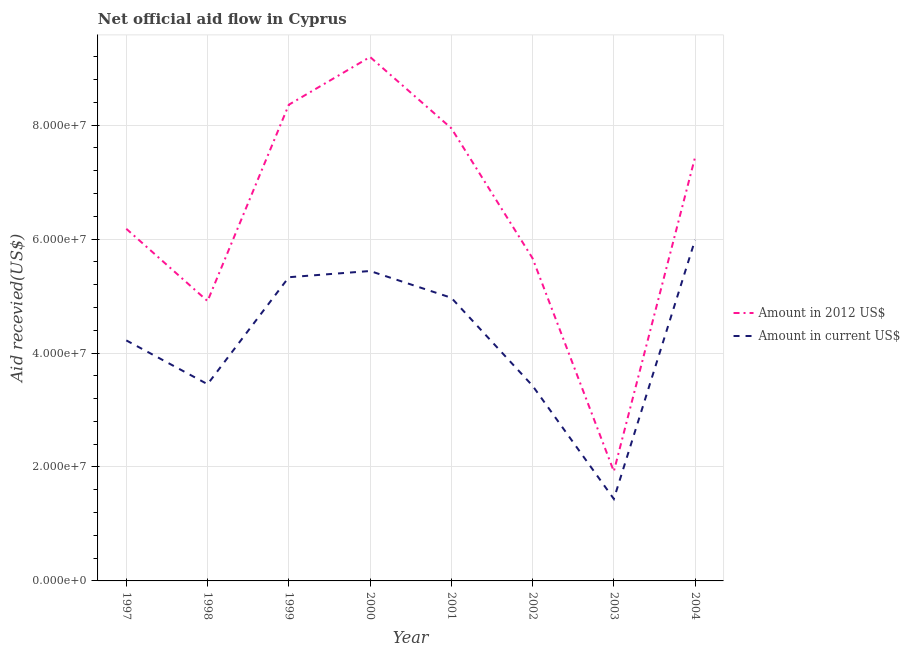How many different coloured lines are there?
Give a very brief answer. 2. What is the amount of aid received(expressed in 2012 us$) in 2002?
Offer a very short reply. 5.66e+07. Across all years, what is the maximum amount of aid received(expressed in us$)?
Give a very brief answer. 5.99e+07. Across all years, what is the minimum amount of aid received(expressed in 2012 us$)?
Your response must be concise. 1.92e+07. What is the total amount of aid received(expressed in us$) in the graph?
Provide a succinct answer. 3.43e+08. What is the difference between the amount of aid received(expressed in us$) in 1997 and that in 2002?
Give a very brief answer. 7.97e+06. What is the difference between the amount of aid received(expressed in us$) in 1998 and the amount of aid received(expressed in 2012 us$) in 2002?
Provide a short and direct response. -2.21e+07. What is the average amount of aid received(expressed in 2012 us$) per year?
Your response must be concise. 6.45e+07. In the year 1999, what is the difference between the amount of aid received(expressed in 2012 us$) and amount of aid received(expressed in us$)?
Your answer should be compact. 3.03e+07. In how many years, is the amount of aid received(expressed in us$) greater than 56000000 US$?
Make the answer very short. 1. What is the ratio of the amount of aid received(expressed in us$) in 2001 to that in 2002?
Offer a very short reply. 1.45. Is the amount of aid received(expressed in us$) in 1997 less than that in 1998?
Offer a very short reply. No. What is the difference between the highest and the second highest amount of aid received(expressed in 2012 us$)?
Give a very brief answer. 8.38e+06. What is the difference between the highest and the lowest amount of aid received(expressed in us$)?
Your response must be concise. 4.55e+07. Is the sum of the amount of aid received(expressed in us$) in 1998 and 2004 greater than the maximum amount of aid received(expressed in 2012 us$) across all years?
Ensure brevity in your answer.  Yes. Does the amount of aid received(expressed in us$) monotonically increase over the years?
Keep it short and to the point. No. Is the amount of aid received(expressed in us$) strictly less than the amount of aid received(expressed in 2012 us$) over the years?
Offer a terse response. Yes. How many lines are there?
Your answer should be very brief. 2. How many years are there in the graph?
Your answer should be compact. 8. Does the graph contain any zero values?
Make the answer very short. No. Does the graph contain grids?
Offer a very short reply. Yes. Where does the legend appear in the graph?
Your answer should be compact. Center right. How many legend labels are there?
Keep it short and to the point. 2. What is the title of the graph?
Ensure brevity in your answer.  Net official aid flow in Cyprus. What is the label or title of the Y-axis?
Give a very brief answer. Aid recevied(US$). What is the Aid recevied(US$) of Amount in 2012 US$ in 1997?
Keep it short and to the point. 6.18e+07. What is the Aid recevied(US$) in Amount in current US$ in 1997?
Give a very brief answer. 4.22e+07. What is the Aid recevied(US$) of Amount in 2012 US$ in 1998?
Your answer should be very brief. 4.91e+07. What is the Aid recevied(US$) in Amount in current US$ in 1998?
Give a very brief answer. 3.45e+07. What is the Aid recevied(US$) in Amount in 2012 US$ in 1999?
Your response must be concise. 8.36e+07. What is the Aid recevied(US$) of Amount in current US$ in 1999?
Offer a very short reply. 5.33e+07. What is the Aid recevied(US$) in Amount in 2012 US$ in 2000?
Keep it short and to the point. 9.20e+07. What is the Aid recevied(US$) of Amount in current US$ in 2000?
Offer a terse response. 5.44e+07. What is the Aid recevied(US$) of Amount in 2012 US$ in 2001?
Offer a very short reply. 7.95e+07. What is the Aid recevied(US$) of Amount in current US$ in 2001?
Make the answer very short. 4.97e+07. What is the Aid recevied(US$) in Amount in 2012 US$ in 2002?
Give a very brief answer. 5.66e+07. What is the Aid recevied(US$) of Amount in current US$ in 2002?
Provide a short and direct response. 3.42e+07. What is the Aid recevied(US$) of Amount in 2012 US$ in 2003?
Give a very brief answer. 1.92e+07. What is the Aid recevied(US$) of Amount in current US$ in 2003?
Keep it short and to the point. 1.44e+07. What is the Aid recevied(US$) of Amount in 2012 US$ in 2004?
Give a very brief answer. 7.44e+07. What is the Aid recevied(US$) in Amount in current US$ in 2004?
Your answer should be compact. 5.99e+07. Across all years, what is the maximum Aid recevied(US$) in Amount in 2012 US$?
Your answer should be compact. 9.20e+07. Across all years, what is the maximum Aid recevied(US$) of Amount in current US$?
Make the answer very short. 5.99e+07. Across all years, what is the minimum Aid recevied(US$) in Amount in 2012 US$?
Provide a short and direct response. 1.92e+07. Across all years, what is the minimum Aid recevied(US$) of Amount in current US$?
Provide a succinct answer. 1.44e+07. What is the total Aid recevied(US$) of Amount in 2012 US$ in the graph?
Offer a very short reply. 5.16e+08. What is the total Aid recevied(US$) of Amount in current US$ in the graph?
Offer a very short reply. 3.43e+08. What is the difference between the Aid recevied(US$) of Amount in 2012 US$ in 1997 and that in 1998?
Make the answer very short. 1.27e+07. What is the difference between the Aid recevied(US$) of Amount in current US$ in 1997 and that in 1998?
Your answer should be compact. 7.69e+06. What is the difference between the Aid recevied(US$) of Amount in 2012 US$ in 1997 and that in 1999?
Your answer should be very brief. -2.18e+07. What is the difference between the Aid recevied(US$) of Amount in current US$ in 1997 and that in 1999?
Your answer should be compact. -1.11e+07. What is the difference between the Aid recevied(US$) in Amount in 2012 US$ in 1997 and that in 2000?
Provide a succinct answer. -3.02e+07. What is the difference between the Aid recevied(US$) of Amount in current US$ in 1997 and that in 2000?
Keep it short and to the point. -1.22e+07. What is the difference between the Aid recevied(US$) of Amount in 2012 US$ in 1997 and that in 2001?
Your answer should be compact. -1.76e+07. What is the difference between the Aid recevied(US$) of Amount in current US$ in 1997 and that in 2001?
Offer a terse response. -7.48e+06. What is the difference between the Aid recevied(US$) in Amount in 2012 US$ in 1997 and that in 2002?
Provide a succinct answer. 5.18e+06. What is the difference between the Aid recevied(US$) in Amount in current US$ in 1997 and that in 2002?
Provide a short and direct response. 7.97e+06. What is the difference between the Aid recevied(US$) of Amount in 2012 US$ in 1997 and that in 2003?
Keep it short and to the point. 4.26e+07. What is the difference between the Aid recevied(US$) in Amount in current US$ in 1997 and that in 2003?
Make the answer very short. 2.78e+07. What is the difference between the Aid recevied(US$) of Amount in 2012 US$ in 1997 and that in 2004?
Provide a succinct answer. -1.26e+07. What is the difference between the Aid recevied(US$) of Amount in current US$ in 1997 and that in 2004?
Your answer should be compact. -1.76e+07. What is the difference between the Aid recevied(US$) in Amount in 2012 US$ in 1998 and that in 1999?
Offer a very short reply. -3.45e+07. What is the difference between the Aid recevied(US$) in Amount in current US$ in 1998 and that in 1999?
Provide a short and direct response. -1.88e+07. What is the difference between the Aid recevied(US$) in Amount in 2012 US$ in 1998 and that in 2000?
Offer a terse response. -4.28e+07. What is the difference between the Aid recevied(US$) in Amount in current US$ in 1998 and that in 2000?
Your response must be concise. -1.99e+07. What is the difference between the Aid recevied(US$) in Amount in 2012 US$ in 1998 and that in 2001?
Your response must be concise. -3.03e+07. What is the difference between the Aid recevied(US$) in Amount in current US$ in 1998 and that in 2001?
Your response must be concise. -1.52e+07. What is the difference between the Aid recevied(US$) in Amount in 2012 US$ in 1998 and that in 2002?
Offer a very short reply. -7.51e+06. What is the difference between the Aid recevied(US$) in Amount in current US$ in 1998 and that in 2002?
Your answer should be compact. 2.80e+05. What is the difference between the Aid recevied(US$) of Amount in 2012 US$ in 1998 and that in 2003?
Your answer should be very brief. 2.99e+07. What is the difference between the Aid recevied(US$) of Amount in current US$ in 1998 and that in 2003?
Ensure brevity in your answer.  2.01e+07. What is the difference between the Aid recevied(US$) of Amount in 2012 US$ in 1998 and that in 2004?
Offer a terse response. -2.53e+07. What is the difference between the Aid recevied(US$) in Amount in current US$ in 1998 and that in 2004?
Give a very brief answer. -2.53e+07. What is the difference between the Aid recevied(US$) of Amount in 2012 US$ in 1999 and that in 2000?
Make the answer very short. -8.38e+06. What is the difference between the Aid recevied(US$) of Amount in current US$ in 1999 and that in 2000?
Offer a terse response. -1.09e+06. What is the difference between the Aid recevied(US$) in Amount in 2012 US$ in 1999 and that in 2001?
Ensure brevity in your answer.  4.13e+06. What is the difference between the Aid recevied(US$) in Amount in current US$ in 1999 and that in 2001?
Give a very brief answer. 3.61e+06. What is the difference between the Aid recevied(US$) in Amount in 2012 US$ in 1999 and that in 2002?
Your answer should be very brief. 2.70e+07. What is the difference between the Aid recevied(US$) of Amount in current US$ in 1999 and that in 2002?
Offer a terse response. 1.91e+07. What is the difference between the Aid recevied(US$) in Amount in 2012 US$ in 1999 and that in 2003?
Your answer should be compact. 6.44e+07. What is the difference between the Aid recevied(US$) in Amount in current US$ in 1999 and that in 2003?
Offer a terse response. 3.89e+07. What is the difference between the Aid recevied(US$) of Amount in 2012 US$ in 1999 and that in 2004?
Your answer should be compact. 9.20e+06. What is the difference between the Aid recevied(US$) in Amount in current US$ in 1999 and that in 2004?
Your answer should be compact. -6.55e+06. What is the difference between the Aid recevied(US$) of Amount in 2012 US$ in 2000 and that in 2001?
Make the answer very short. 1.25e+07. What is the difference between the Aid recevied(US$) in Amount in current US$ in 2000 and that in 2001?
Make the answer very short. 4.70e+06. What is the difference between the Aid recevied(US$) in Amount in 2012 US$ in 2000 and that in 2002?
Make the answer very short. 3.53e+07. What is the difference between the Aid recevied(US$) of Amount in current US$ in 2000 and that in 2002?
Your response must be concise. 2.02e+07. What is the difference between the Aid recevied(US$) in Amount in 2012 US$ in 2000 and that in 2003?
Your response must be concise. 7.27e+07. What is the difference between the Aid recevied(US$) in Amount in current US$ in 2000 and that in 2003?
Your answer should be very brief. 4.00e+07. What is the difference between the Aid recevied(US$) in Amount in 2012 US$ in 2000 and that in 2004?
Your response must be concise. 1.76e+07. What is the difference between the Aid recevied(US$) in Amount in current US$ in 2000 and that in 2004?
Your answer should be compact. -5.46e+06. What is the difference between the Aid recevied(US$) in Amount in 2012 US$ in 2001 and that in 2002?
Give a very brief answer. 2.28e+07. What is the difference between the Aid recevied(US$) in Amount in current US$ in 2001 and that in 2002?
Make the answer very short. 1.54e+07. What is the difference between the Aid recevied(US$) in Amount in 2012 US$ in 2001 and that in 2003?
Make the answer very short. 6.02e+07. What is the difference between the Aid recevied(US$) of Amount in current US$ in 2001 and that in 2003?
Offer a very short reply. 3.53e+07. What is the difference between the Aid recevied(US$) of Amount in 2012 US$ in 2001 and that in 2004?
Keep it short and to the point. 5.07e+06. What is the difference between the Aid recevied(US$) in Amount in current US$ in 2001 and that in 2004?
Ensure brevity in your answer.  -1.02e+07. What is the difference between the Aid recevied(US$) of Amount in 2012 US$ in 2002 and that in 2003?
Ensure brevity in your answer.  3.74e+07. What is the difference between the Aid recevied(US$) in Amount in current US$ in 2002 and that in 2003?
Keep it short and to the point. 1.99e+07. What is the difference between the Aid recevied(US$) of Amount in 2012 US$ in 2002 and that in 2004?
Your answer should be compact. -1.78e+07. What is the difference between the Aid recevied(US$) of Amount in current US$ in 2002 and that in 2004?
Give a very brief answer. -2.56e+07. What is the difference between the Aid recevied(US$) in Amount in 2012 US$ in 2003 and that in 2004?
Your response must be concise. -5.52e+07. What is the difference between the Aid recevied(US$) of Amount in current US$ in 2003 and that in 2004?
Provide a succinct answer. -4.55e+07. What is the difference between the Aid recevied(US$) of Amount in 2012 US$ in 1997 and the Aid recevied(US$) of Amount in current US$ in 1998?
Provide a short and direct response. 2.73e+07. What is the difference between the Aid recevied(US$) of Amount in 2012 US$ in 1997 and the Aid recevied(US$) of Amount in current US$ in 1999?
Make the answer very short. 8.50e+06. What is the difference between the Aid recevied(US$) in Amount in 2012 US$ in 1997 and the Aid recevied(US$) in Amount in current US$ in 2000?
Your answer should be compact. 7.41e+06. What is the difference between the Aid recevied(US$) of Amount in 2012 US$ in 1997 and the Aid recevied(US$) of Amount in current US$ in 2001?
Give a very brief answer. 1.21e+07. What is the difference between the Aid recevied(US$) of Amount in 2012 US$ in 1997 and the Aid recevied(US$) of Amount in current US$ in 2002?
Make the answer very short. 2.76e+07. What is the difference between the Aid recevied(US$) in Amount in 2012 US$ in 1997 and the Aid recevied(US$) in Amount in current US$ in 2003?
Ensure brevity in your answer.  4.74e+07. What is the difference between the Aid recevied(US$) of Amount in 2012 US$ in 1997 and the Aid recevied(US$) of Amount in current US$ in 2004?
Keep it short and to the point. 1.95e+06. What is the difference between the Aid recevied(US$) of Amount in 2012 US$ in 1998 and the Aid recevied(US$) of Amount in current US$ in 1999?
Your answer should be very brief. -4.19e+06. What is the difference between the Aid recevied(US$) of Amount in 2012 US$ in 1998 and the Aid recevied(US$) of Amount in current US$ in 2000?
Your response must be concise. -5.28e+06. What is the difference between the Aid recevied(US$) in Amount in 2012 US$ in 1998 and the Aid recevied(US$) in Amount in current US$ in 2001?
Ensure brevity in your answer.  -5.80e+05. What is the difference between the Aid recevied(US$) of Amount in 2012 US$ in 1998 and the Aid recevied(US$) of Amount in current US$ in 2002?
Provide a short and direct response. 1.49e+07. What is the difference between the Aid recevied(US$) in Amount in 2012 US$ in 1998 and the Aid recevied(US$) in Amount in current US$ in 2003?
Give a very brief answer. 3.47e+07. What is the difference between the Aid recevied(US$) in Amount in 2012 US$ in 1998 and the Aid recevied(US$) in Amount in current US$ in 2004?
Your answer should be compact. -1.07e+07. What is the difference between the Aid recevied(US$) in Amount in 2012 US$ in 1999 and the Aid recevied(US$) in Amount in current US$ in 2000?
Your response must be concise. 2.92e+07. What is the difference between the Aid recevied(US$) in Amount in 2012 US$ in 1999 and the Aid recevied(US$) in Amount in current US$ in 2001?
Provide a succinct answer. 3.39e+07. What is the difference between the Aid recevied(US$) of Amount in 2012 US$ in 1999 and the Aid recevied(US$) of Amount in current US$ in 2002?
Your answer should be very brief. 4.93e+07. What is the difference between the Aid recevied(US$) of Amount in 2012 US$ in 1999 and the Aid recevied(US$) of Amount in current US$ in 2003?
Your answer should be very brief. 6.92e+07. What is the difference between the Aid recevied(US$) of Amount in 2012 US$ in 1999 and the Aid recevied(US$) of Amount in current US$ in 2004?
Offer a very short reply. 2.37e+07. What is the difference between the Aid recevied(US$) of Amount in 2012 US$ in 2000 and the Aid recevied(US$) of Amount in current US$ in 2001?
Make the answer very short. 4.23e+07. What is the difference between the Aid recevied(US$) of Amount in 2012 US$ in 2000 and the Aid recevied(US$) of Amount in current US$ in 2002?
Give a very brief answer. 5.77e+07. What is the difference between the Aid recevied(US$) of Amount in 2012 US$ in 2000 and the Aid recevied(US$) of Amount in current US$ in 2003?
Keep it short and to the point. 7.76e+07. What is the difference between the Aid recevied(US$) in Amount in 2012 US$ in 2000 and the Aid recevied(US$) in Amount in current US$ in 2004?
Offer a very short reply. 3.21e+07. What is the difference between the Aid recevied(US$) of Amount in 2012 US$ in 2001 and the Aid recevied(US$) of Amount in current US$ in 2002?
Your answer should be compact. 4.52e+07. What is the difference between the Aid recevied(US$) in Amount in 2012 US$ in 2001 and the Aid recevied(US$) in Amount in current US$ in 2003?
Make the answer very short. 6.51e+07. What is the difference between the Aid recevied(US$) of Amount in 2012 US$ in 2001 and the Aid recevied(US$) of Amount in current US$ in 2004?
Provide a succinct answer. 1.96e+07. What is the difference between the Aid recevied(US$) in Amount in 2012 US$ in 2002 and the Aid recevied(US$) in Amount in current US$ in 2003?
Provide a succinct answer. 4.22e+07. What is the difference between the Aid recevied(US$) in Amount in 2012 US$ in 2002 and the Aid recevied(US$) in Amount in current US$ in 2004?
Keep it short and to the point. -3.23e+06. What is the difference between the Aid recevied(US$) in Amount in 2012 US$ in 2003 and the Aid recevied(US$) in Amount in current US$ in 2004?
Make the answer very short. -4.06e+07. What is the average Aid recevied(US$) of Amount in 2012 US$ per year?
Keep it short and to the point. 6.45e+07. What is the average Aid recevied(US$) of Amount in current US$ per year?
Ensure brevity in your answer.  4.28e+07. In the year 1997, what is the difference between the Aid recevied(US$) of Amount in 2012 US$ and Aid recevied(US$) of Amount in current US$?
Offer a very short reply. 1.96e+07. In the year 1998, what is the difference between the Aid recevied(US$) of Amount in 2012 US$ and Aid recevied(US$) of Amount in current US$?
Keep it short and to the point. 1.46e+07. In the year 1999, what is the difference between the Aid recevied(US$) in Amount in 2012 US$ and Aid recevied(US$) in Amount in current US$?
Make the answer very short. 3.03e+07. In the year 2000, what is the difference between the Aid recevied(US$) of Amount in 2012 US$ and Aid recevied(US$) of Amount in current US$?
Your answer should be very brief. 3.76e+07. In the year 2001, what is the difference between the Aid recevied(US$) of Amount in 2012 US$ and Aid recevied(US$) of Amount in current US$?
Your answer should be compact. 2.98e+07. In the year 2002, what is the difference between the Aid recevied(US$) of Amount in 2012 US$ and Aid recevied(US$) of Amount in current US$?
Your answer should be compact. 2.24e+07. In the year 2003, what is the difference between the Aid recevied(US$) in Amount in 2012 US$ and Aid recevied(US$) in Amount in current US$?
Offer a terse response. 4.84e+06. In the year 2004, what is the difference between the Aid recevied(US$) of Amount in 2012 US$ and Aid recevied(US$) of Amount in current US$?
Ensure brevity in your answer.  1.45e+07. What is the ratio of the Aid recevied(US$) of Amount in 2012 US$ in 1997 to that in 1998?
Offer a very short reply. 1.26. What is the ratio of the Aid recevied(US$) in Amount in current US$ in 1997 to that in 1998?
Offer a very short reply. 1.22. What is the ratio of the Aid recevied(US$) in Amount in 2012 US$ in 1997 to that in 1999?
Keep it short and to the point. 0.74. What is the ratio of the Aid recevied(US$) in Amount in current US$ in 1997 to that in 1999?
Provide a short and direct response. 0.79. What is the ratio of the Aid recevied(US$) in Amount in 2012 US$ in 1997 to that in 2000?
Keep it short and to the point. 0.67. What is the ratio of the Aid recevied(US$) of Amount in current US$ in 1997 to that in 2000?
Offer a very short reply. 0.78. What is the ratio of the Aid recevied(US$) in Amount in 2012 US$ in 1997 to that in 2001?
Offer a very short reply. 0.78. What is the ratio of the Aid recevied(US$) of Amount in current US$ in 1997 to that in 2001?
Offer a terse response. 0.85. What is the ratio of the Aid recevied(US$) of Amount in 2012 US$ in 1997 to that in 2002?
Keep it short and to the point. 1.09. What is the ratio of the Aid recevied(US$) of Amount in current US$ in 1997 to that in 2002?
Provide a short and direct response. 1.23. What is the ratio of the Aid recevied(US$) in Amount in 2012 US$ in 1997 to that in 2003?
Provide a short and direct response. 3.21. What is the ratio of the Aid recevied(US$) of Amount in current US$ in 1997 to that in 2003?
Offer a very short reply. 2.93. What is the ratio of the Aid recevied(US$) of Amount in 2012 US$ in 1997 to that in 2004?
Provide a succinct answer. 0.83. What is the ratio of the Aid recevied(US$) of Amount in current US$ in 1997 to that in 2004?
Ensure brevity in your answer.  0.71. What is the ratio of the Aid recevied(US$) of Amount in 2012 US$ in 1998 to that in 1999?
Offer a very short reply. 0.59. What is the ratio of the Aid recevied(US$) in Amount in current US$ in 1998 to that in 1999?
Keep it short and to the point. 0.65. What is the ratio of the Aid recevied(US$) of Amount in 2012 US$ in 1998 to that in 2000?
Provide a succinct answer. 0.53. What is the ratio of the Aid recevied(US$) in Amount in current US$ in 1998 to that in 2000?
Your answer should be very brief. 0.63. What is the ratio of the Aid recevied(US$) of Amount in 2012 US$ in 1998 to that in 2001?
Give a very brief answer. 0.62. What is the ratio of the Aid recevied(US$) in Amount in current US$ in 1998 to that in 2001?
Your answer should be compact. 0.69. What is the ratio of the Aid recevied(US$) in Amount in 2012 US$ in 1998 to that in 2002?
Provide a succinct answer. 0.87. What is the ratio of the Aid recevied(US$) of Amount in current US$ in 1998 to that in 2002?
Provide a succinct answer. 1.01. What is the ratio of the Aid recevied(US$) of Amount in 2012 US$ in 1998 to that in 2003?
Your answer should be very brief. 2.55. What is the ratio of the Aid recevied(US$) in Amount in current US$ in 1998 to that in 2003?
Provide a succinct answer. 2.4. What is the ratio of the Aid recevied(US$) in Amount in 2012 US$ in 1998 to that in 2004?
Offer a very short reply. 0.66. What is the ratio of the Aid recevied(US$) of Amount in current US$ in 1998 to that in 2004?
Ensure brevity in your answer.  0.58. What is the ratio of the Aid recevied(US$) of Amount in 2012 US$ in 1999 to that in 2000?
Your response must be concise. 0.91. What is the ratio of the Aid recevied(US$) in Amount in 2012 US$ in 1999 to that in 2001?
Offer a very short reply. 1.05. What is the ratio of the Aid recevied(US$) of Amount in current US$ in 1999 to that in 2001?
Keep it short and to the point. 1.07. What is the ratio of the Aid recevied(US$) of Amount in 2012 US$ in 1999 to that in 2002?
Your answer should be compact. 1.48. What is the ratio of the Aid recevied(US$) in Amount in current US$ in 1999 to that in 2002?
Provide a short and direct response. 1.56. What is the ratio of the Aid recevied(US$) of Amount in 2012 US$ in 1999 to that in 2003?
Provide a short and direct response. 4.35. What is the ratio of the Aid recevied(US$) in Amount in current US$ in 1999 to that in 2003?
Offer a terse response. 3.7. What is the ratio of the Aid recevied(US$) in Amount in 2012 US$ in 1999 to that in 2004?
Your response must be concise. 1.12. What is the ratio of the Aid recevied(US$) of Amount in current US$ in 1999 to that in 2004?
Make the answer very short. 0.89. What is the ratio of the Aid recevied(US$) in Amount in 2012 US$ in 2000 to that in 2001?
Provide a succinct answer. 1.16. What is the ratio of the Aid recevied(US$) of Amount in current US$ in 2000 to that in 2001?
Ensure brevity in your answer.  1.09. What is the ratio of the Aid recevied(US$) in Amount in 2012 US$ in 2000 to that in 2002?
Your answer should be compact. 1.62. What is the ratio of the Aid recevied(US$) of Amount in current US$ in 2000 to that in 2002?
Give a very brief answer. 1.59. What is the ratio of the Aid recevied(US$) of Amount in 2012 US$ in 2000 to that in 2003?
Provide a short and direct response. 4.78. What is the ratio of the Aid recevied(US$) of Amount in current US$ in 2000 to that in 2003?
Your response must be concise. 3.78. What is the ratio of the Aid recevied(US$) of Amount in 2012 US$ in 2000 to that in 2004?
Offer a terse response. 1.24. What is the ratio of the Aid recevied(US$) of Amount in current US$ in 2000 to that in 2004?
Ensure brevity in your answer.  0.91. What is the ratio of the Aid recevied(US$) in Amount in 2012 US$ in 2001 to that in 2002?
Offer a terse response. 1.4. What is the ratio of the Aid recevied(US$) of Amount in current US$ in 2001 to that in 2002?
Provide a succinct answer. 1.45. What is the ratio of the Aid recevied(US$) in Amount in 2012 US$ in 2001 to that in 2003?
Offer a very short reply. 4.13. What is the ratio of the Aid recevied(US$) of Amount in current US$ in 2001 to that in 2003?
Give a very brief answer. 3.45. What is the ratio of the Aid recevied(US$) of Amount in 2012 US$ in 2001 to that in 2004?
Give a very brief answer. 1.07. What is the ratio of the Aid recevied(US$) in Amount in current US$ in 2001 to that in 2004?
Provide a succinct answer. 0.83. What is the ratio of the Aid recevied(US$) in Amount in 2012 US$ in 2002 to that in 2003?
Your answer should be compact. 2.94. What is the ratio of the Aid recevied(US$) in Amount in current US$ in 2002 to that in 2003?
Provide a succinct answer. 2.38. What is the ratio of the Aid recevied(US$) of Amount in 2012 US$ in 2002 to that in 2004?
Offer a terse response. 0.76. What is the ratio of the Aid recevied(US$) of Amount in current US$ in 2002 to that in 2004?
Keep it short and to the point. 0.57. What is the ratio of the Aid recevied(US$) in Amount in 2012 US$ in 2003 to that in 2004?
Provide a short and direct response. 0.26. What is the ratio of the Aid recevied(US$) in Amount in current US$ in 2003 to that in 2004?
Make the answer very short. 0.24. What is the difference between the highest and the second highest Aid recevied(US$) of Amount in 2012 US$?
Ensure brevity in your answer.  8.38e+06. What is the difference between the highest and the second highest Aid recevied(US$) in Amount in current US$?
Your answer should be very brief. 5.46e+06. What is the difference between the highest and the lowest Aid recevied(US$) in Amount in 2012 US$?
Give a very brief answer. 7.27e+07. What is the difference between the highest and the lowest Aid recevied(US$) of Amount in current US$?
Provide a short and direct response. 4.55e+07. 